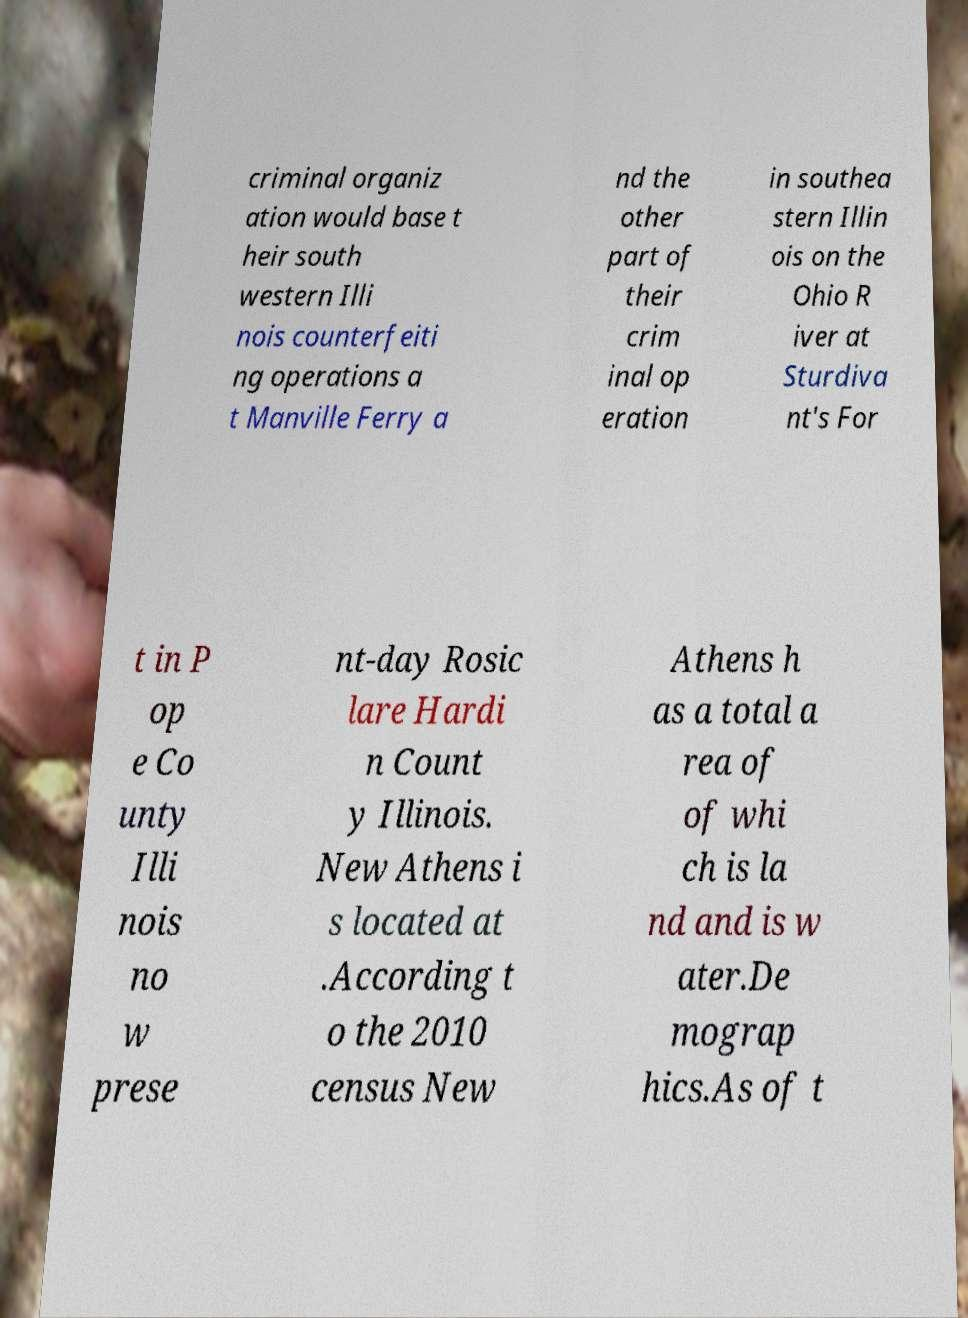Can you accurately transcribe the text from the provided image for me? criminal organiz ation would base t heir south western Illi nois counterfeiti ng operations a t Manville Ferry a nd the other part of their crim inal op eration in southea stern Illin ois on the Ohio R iver at Sturdiva nt's For t in P op e Co unty Illi nois no w prese nt-day Rosic lare Hardi n Count y Illinois. New Athens i s located at .According t o the 2010 census New Athens h as a total a rea of of whi ch is la nd and is w ater.De mograp hics.As of t 